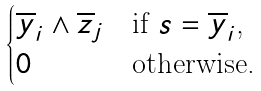<formula> <loc_0><loc_0><loc_500><loc_500>\begin{cases} \overline { y } _ { i } \wedge \overline { z } _ { j } & \text {if $s = \overline{y}_{i}$,} \\ 0 & \text {otherwise.} \\ \end{cases}</formula> 